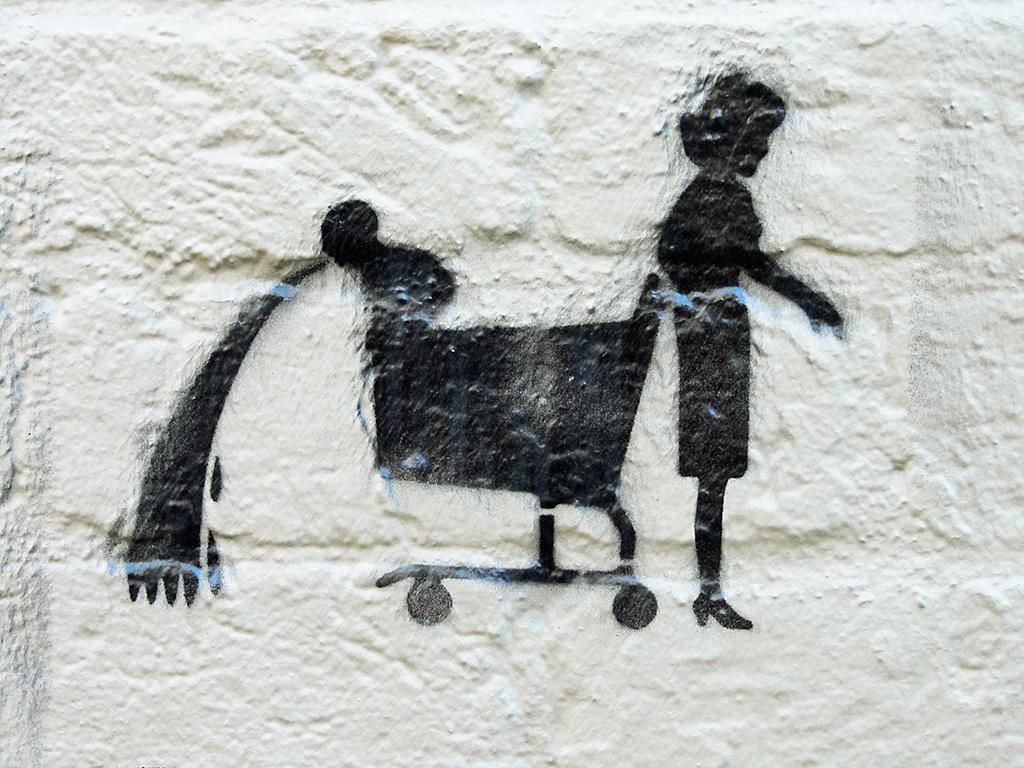Could you give a brief overview of what you see in this image? In the foreground of this image, there is a painting of a woman and a wheel cart on the wall. 